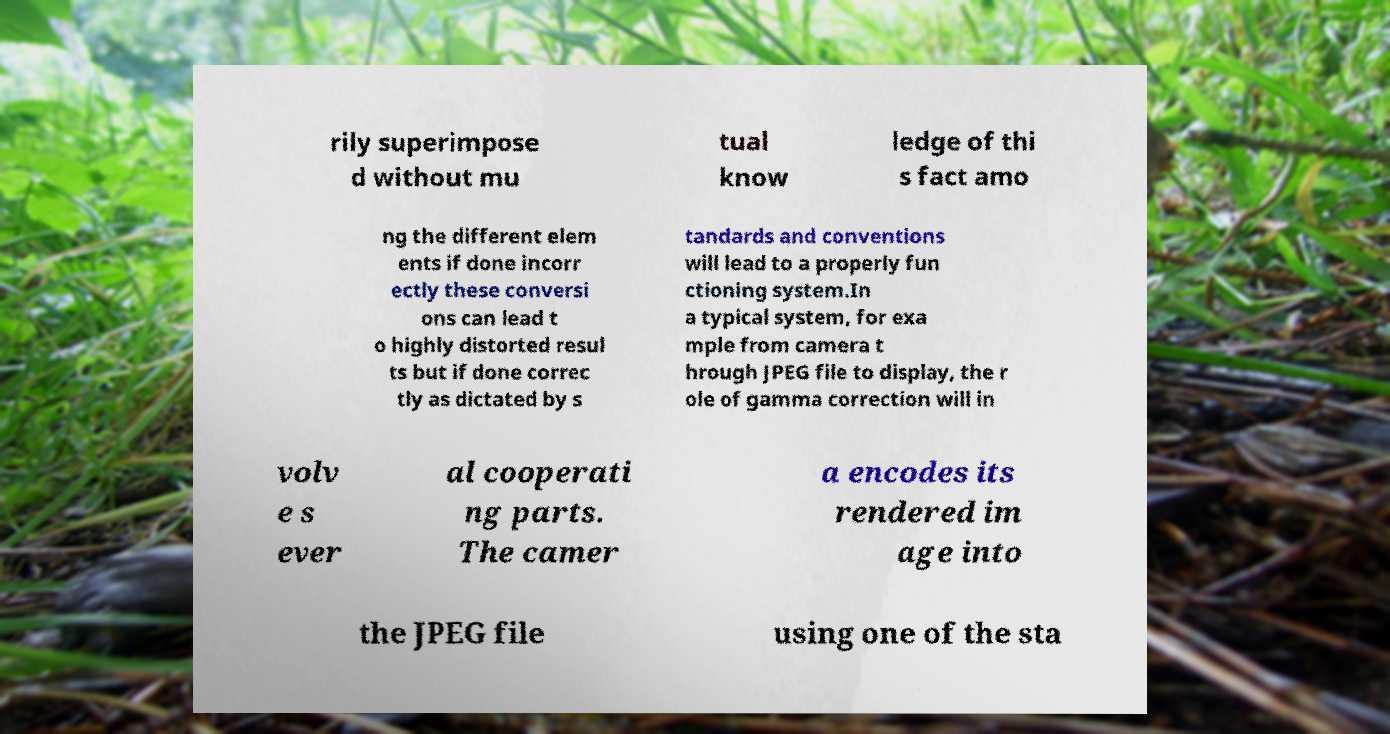What messages or text are displayed in this image? I need them in a readable, typed format. rily superimpose d without mu tual know ledge of thi s fact amo ng the different elem ents if done incorr ectly these conversi ons can lead t o highly distorted resul ts but if done correc tly as dictated by s tandards and conventions will lead to a properly fun ctioning system.In a typical system, for exa mple from camera t hrough JPEG file to display, the r ole of gamma correction will in volv e s ever al cooperati ng parts. The camer a encodes its rendered im age into the JPEG file using one of the sta 